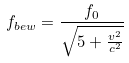<formula> <loc_0><loc_0><loc_500><loc_500>f _ { b e w } = \frac { f _ { 0 } } { \sqrt { 5 + \frac { v ^ { 2 } } { c ^ { 2 } } } }</formula> 